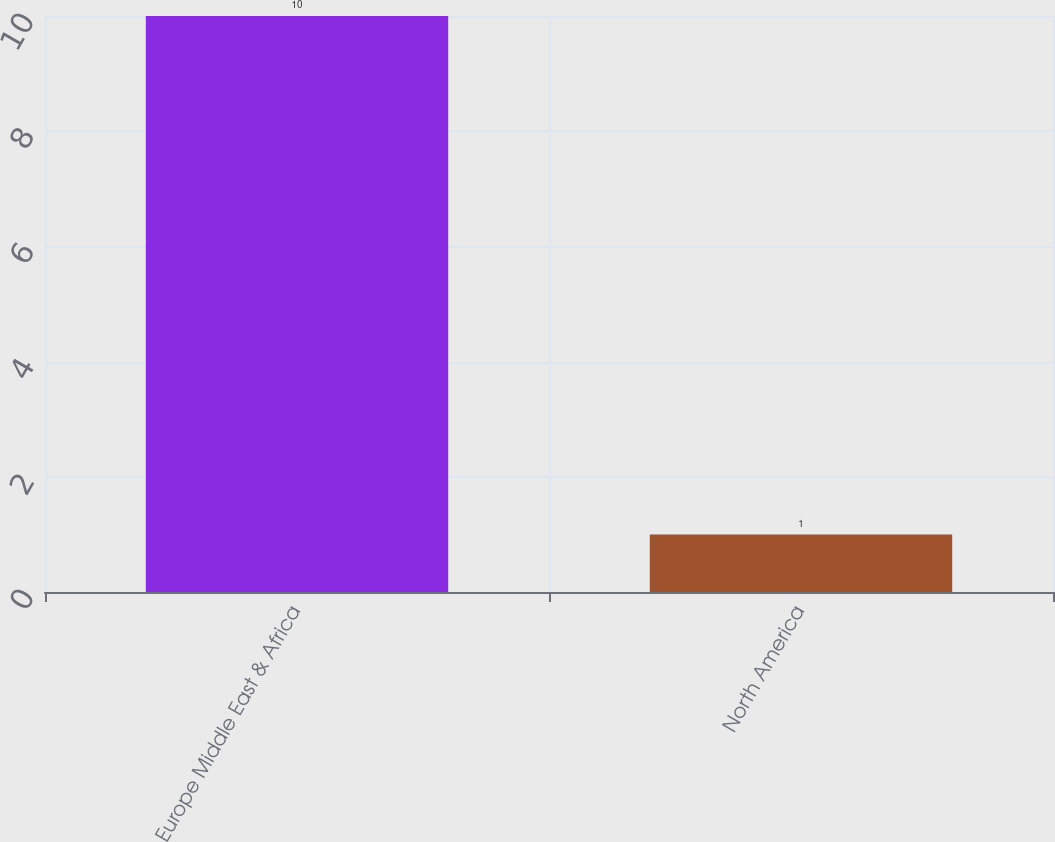Convert chart. <chart><loc_0><loc_0><loc_500><loc_500><bar_chart><fcel>Europe Middle East & Africa<fcel>North America<nl><fcel>10<fcel>1<nl></chart> 